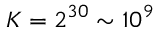Convert formula to latex. <formula><loc_0><loc_0><loc_500><loc_500>K = 2 ^ { 3 0 } \sim 1 0 ^ { 9 }</formula> 